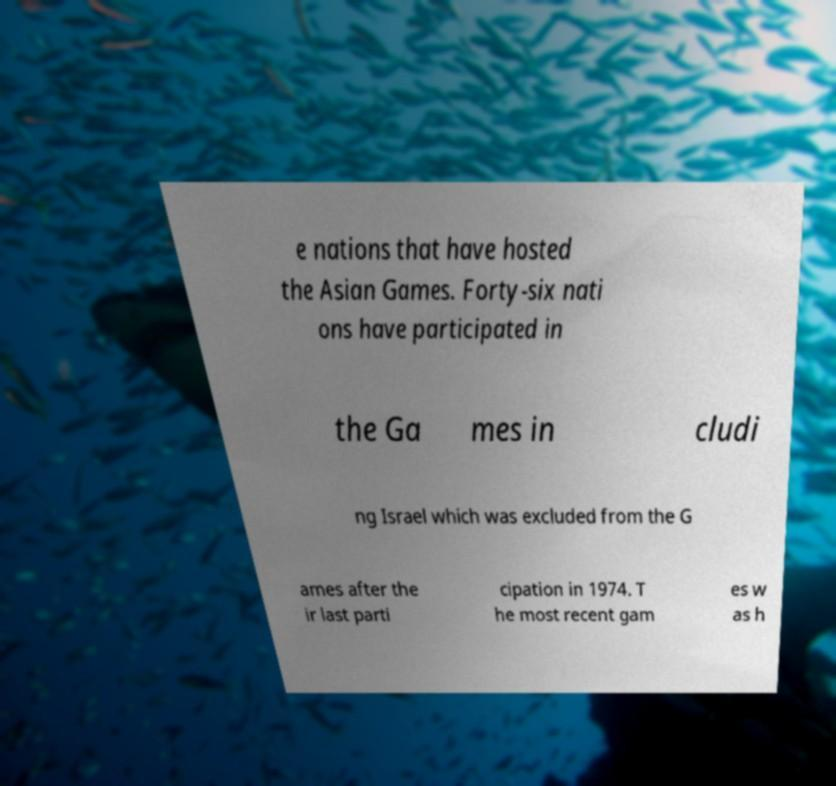What messages or text are displayed in this image? I need them in a readable, typed format. e nations that have hosted the Asian Games. Forty-six nati ons have participated in the Ga mes in cludi ng Israel which was excluded from the G ames after the ir last parti cipation in 1974. T he most recent gam es w as h 